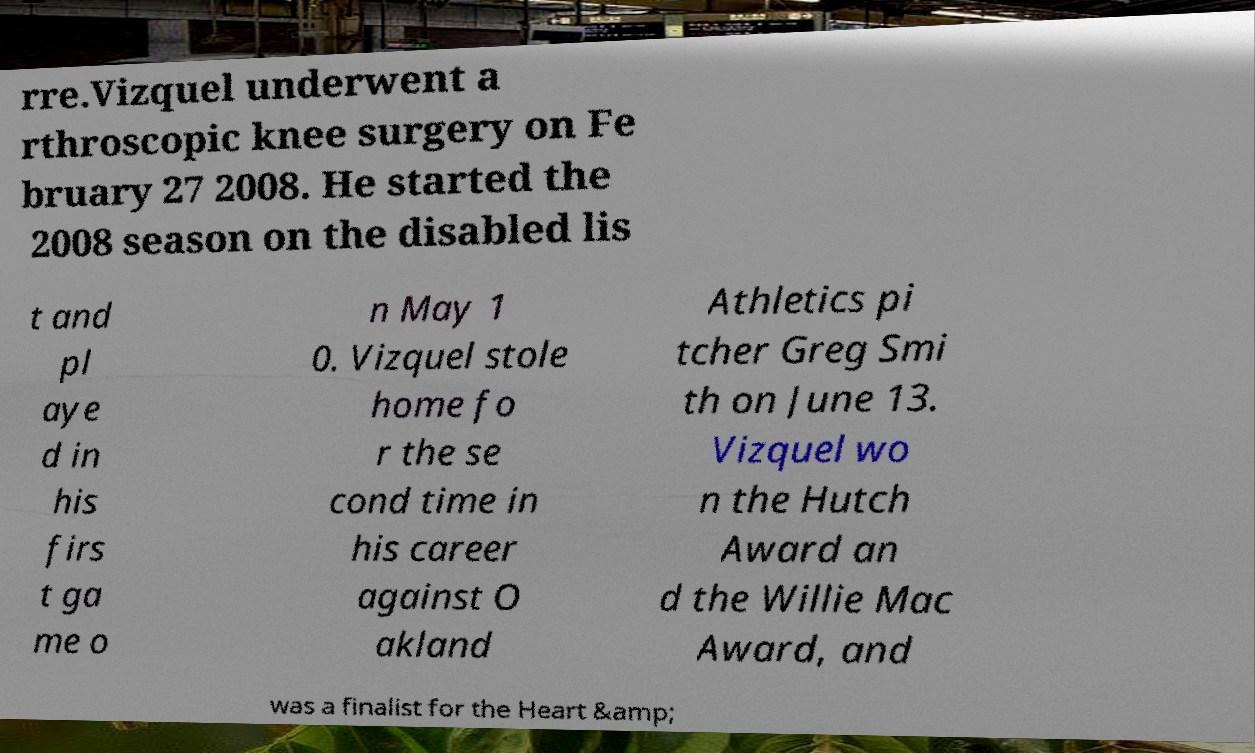Can you accurately transcribe the text from the provided image for me? rre.Vizquel underwent a rthroscopic knee surgery on Fe bruary 27 2008. He started the 2008 season on the disabled lis t and pl aye d in his firs t ga me o n May 1 0. Vizquel stole home fo r the se cond time in his career against O akland Athletics pi tcher Greg Smi th on June 13. Vizquel wo n the Hutch Award an d the Willie Mac Award, and was a finalist for the Heart &amp; 